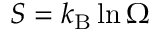<formula> <loc_0><loc_0><loc_500><loc_500>S = k _ { B } \ln \Omega</formula> 